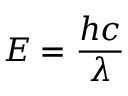Convert formula to latex. <formula><loc_0><loc_0><loc_500><loc_500>E = { \frac { h c } { \lambda } }</formula> 